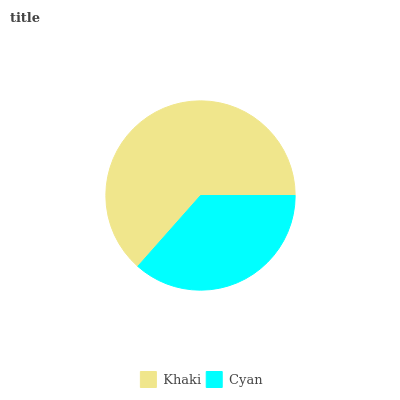Is Cyan the minimum?
Answer yes or no. Yes. Is Khaki the maximum?
Answer yes or no. Yes. Is Cyan the maximum?
Answer yes or no. No. Is Khaki greater than Cyan?
Answer yes or no. Yes. Is Cyan less than Khaki?
Answer yes or no. Yes. Is Cyan greater than Khaki?
Answer yes or no. No. Is Khaki less than Cyan?
Answer yes or no. No. Is Khaki the high median?
Answer yes or no. Yes. Is Cyan the low median?
Answer yes or no. Yes. Is Cyan the high median?
Answer yes or no. No. Is Khaki the low median?
Answer yes or no. No. 